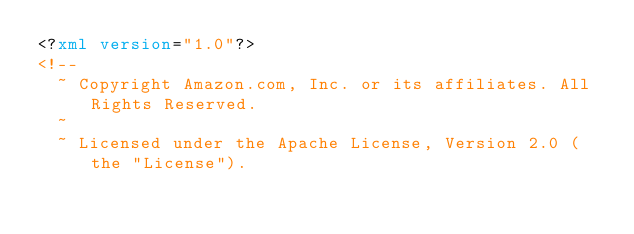Convert code to text. <code><loc_0><loc_0><loc_500><loc_500><_XML_><?xml version="1.0"?>
<!--
  ~ Copyright Amazon.com, Inc. or its affiliates. All Rights Reserved.
  ~
  ~ Licensed under the Apache License, Version 2.0 (the "License").</code> 